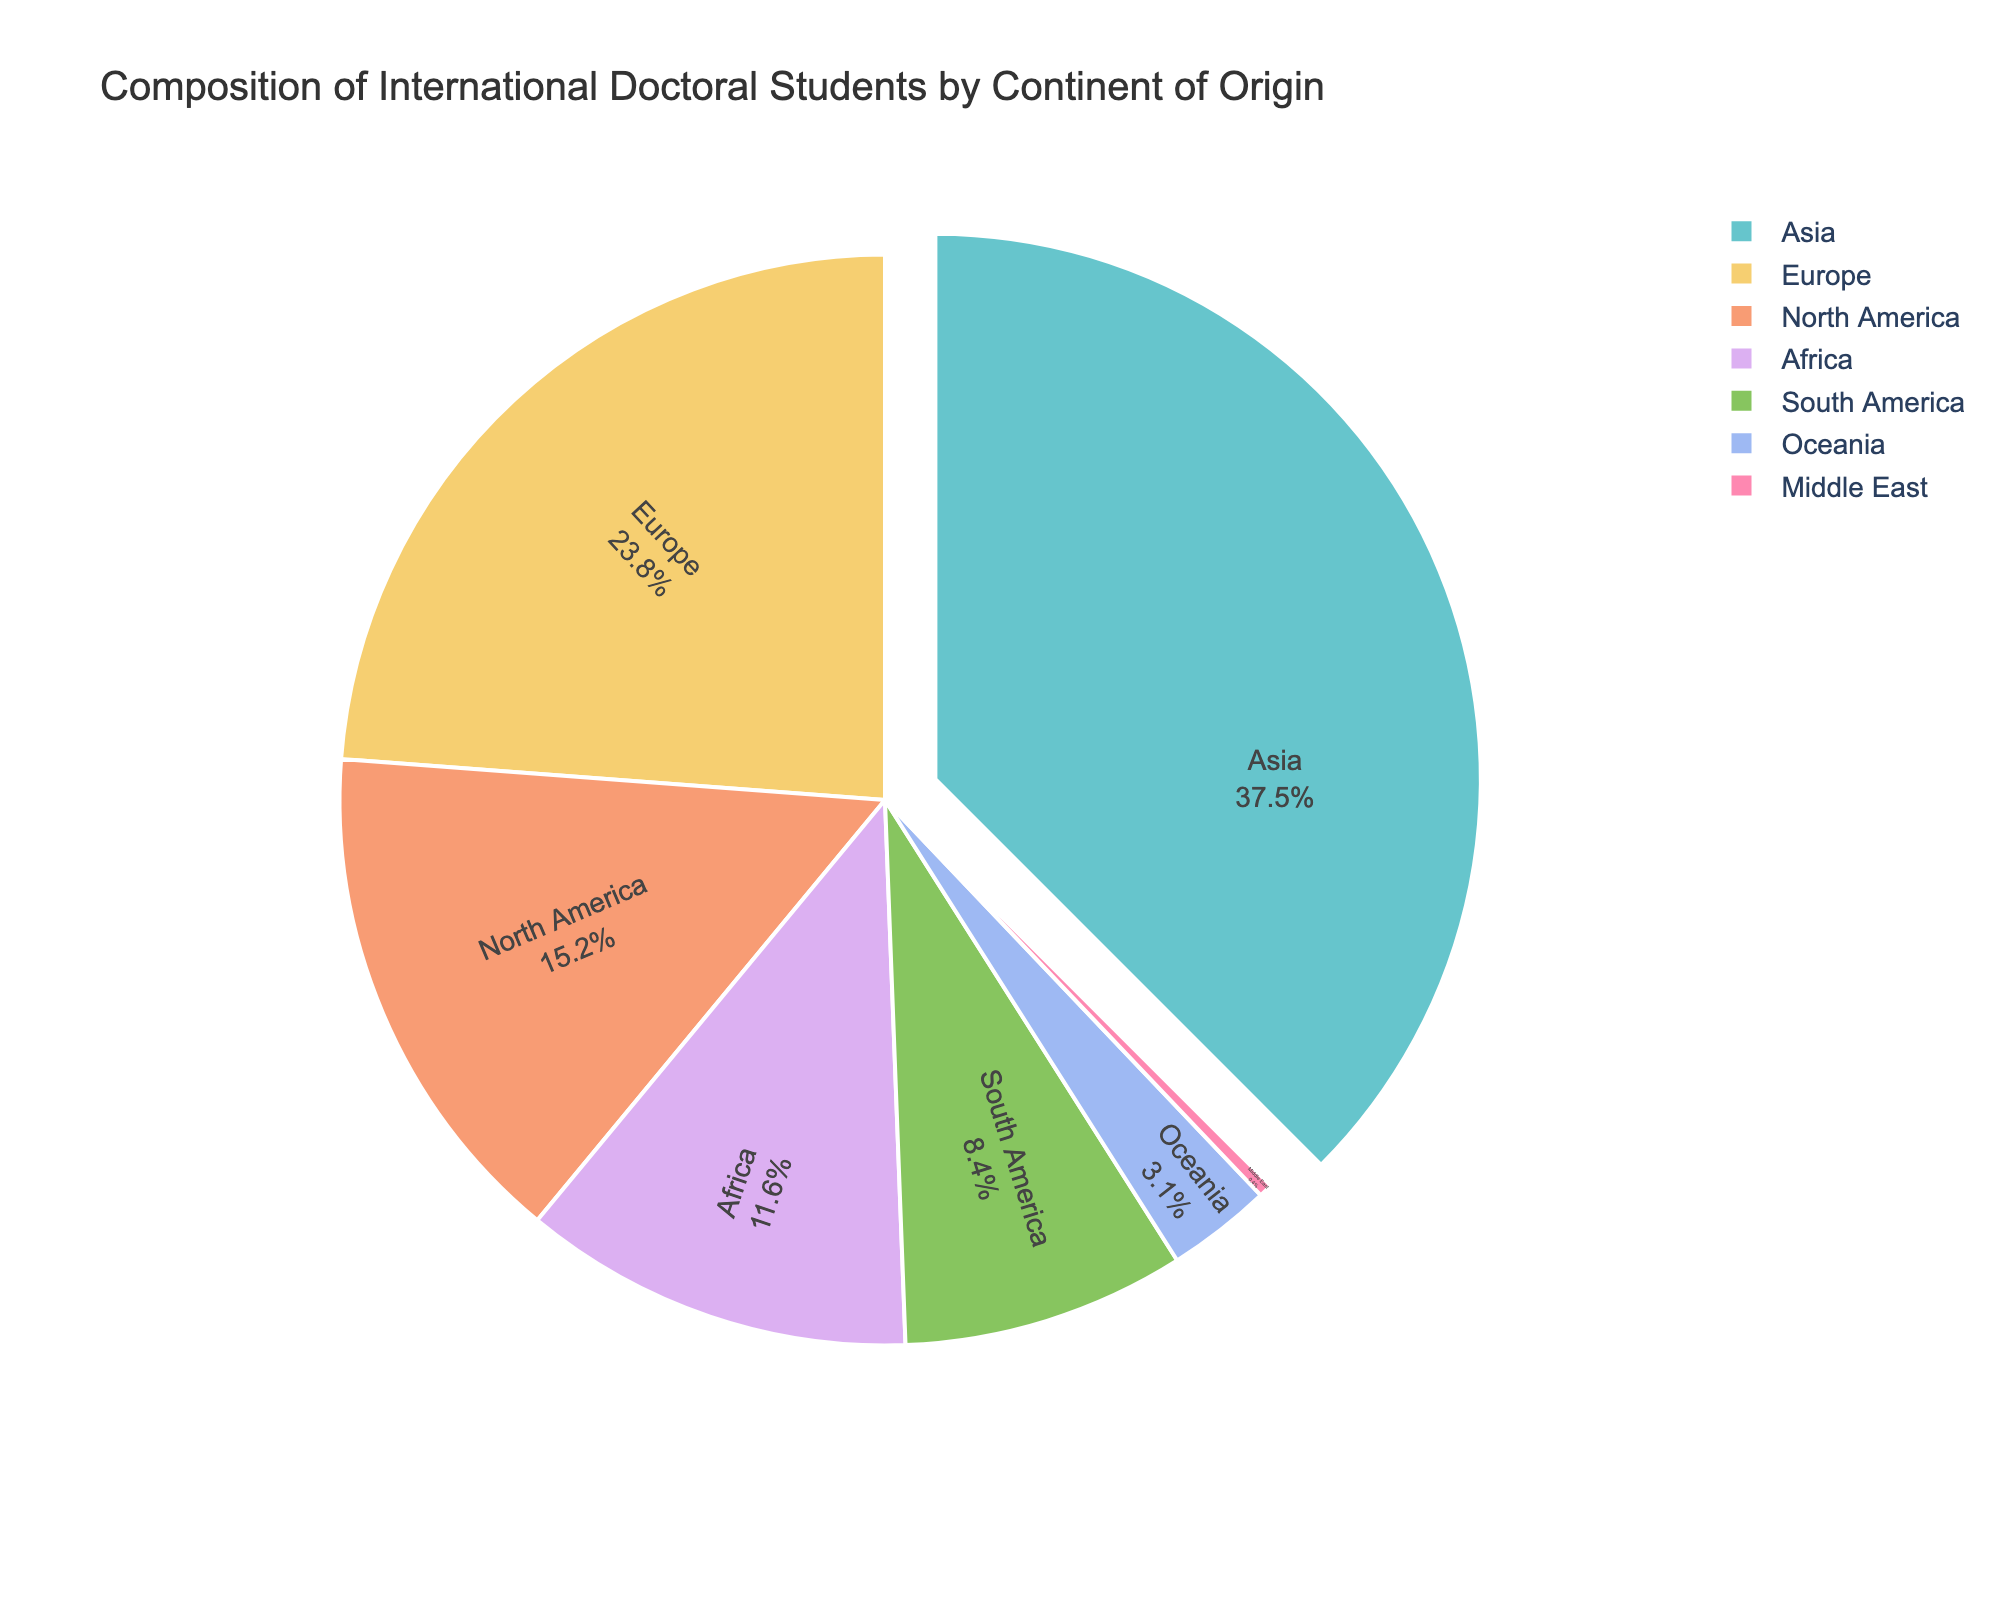What is the percentage of international doctoral students from Asia? The figure indicates the percentage of students from each continent. Locate the segment labeled "Asia" and read the percentage value.
Answer: 37.5% Which continent has the least representation among international doctoral students? The figure represents each continent's percentage of students. Find the segment with the smallest percentage value, which is "Middle East."
Answer: Middle East How much higher is the percentage of students from Europe compared to those from Africa? Identify the percentage values for Europe (23.8%) and Africa (11.6%). Calculate the difference: 23.8% - 11.6%.
Answer: 12.2% What percentage of international doctoral students come from North and South America combined? Identify the percentages for North America (15.2%) and South America (8.4%). Add them together: 15.2% + 8.4%.
Answer: 23.6% Which continent has the second highest representation among international doctoral students? Locate the segment with the highest percentage, Asia (37.5%), followed by the next highest, Europe (23.8%).
Answer: Europe Compare the percentages of students from Oceania and the Middle East. Which is larger and by how much? Identify the percentages for Oceania (3.1%) and the Middle East (0.4%). Compute the difference: 3.1% - 0.4%.
Answer: Oceania by 2.7% What is the median percentage of international doctoral students among the continents? Arrange the percentages in ascending order (0.4%, 3.1%, 8.4%, 11.6%, 15.2%, 23.8%, 37.5%). The median is the middle value in the ordered list, which is 11.6%.
Answer: 11.6% What colors are used to represent Europe and Oceania in the pie chart? Visually inspect the pie chart and note the colors used for the segments labeled "Europe" and "Oceania."
Answer: **(Leave the accurate color identification to the visual inspection)** How many continents have a representation of less than 10% in the international doctoral student population? Identify the segments with percentage values less than 10% and count them: South America (8.4%), Oceania (3.1%), Middle East (0.4%). This totals three continents.
Answer: 3 What is the percentage difference between the continents with the highest and lowest representations? Find the percentage for the highest (Asia, 37.5%) and the lowest (Middle East, 0.4%). Subtract the lowest from the highest: 37.5% - 0.4%.
Answer: 37.1% 